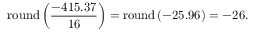<formula> <loc_0><loc_0><loc_500><loc_500>r o u n d \left ( { \frac { - 4 1 5 . 3 7 } { 1 6 } } \right ) = r o u n d \left ( - 2 5 . 9 6 \right ) = - 2 6 .</formula> 